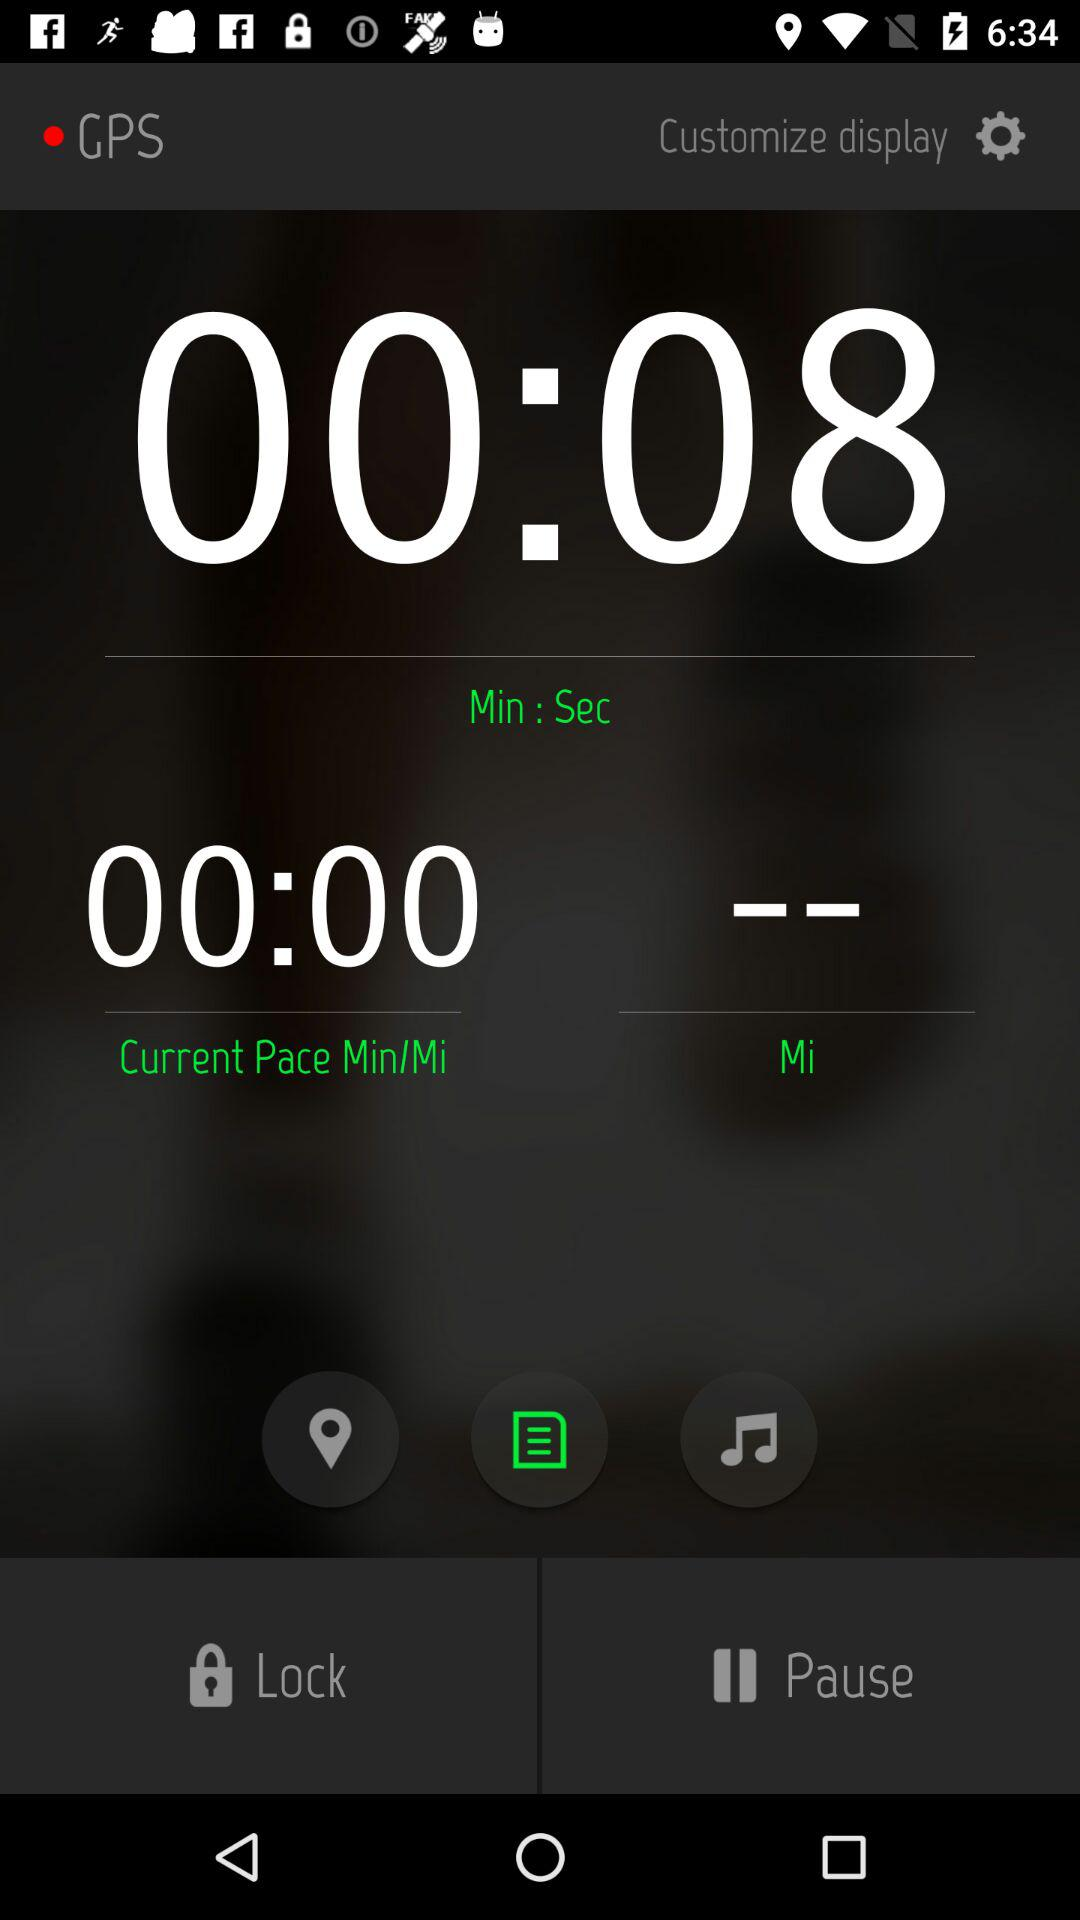What is the current pace min/mi? The current pace is 00:00. 